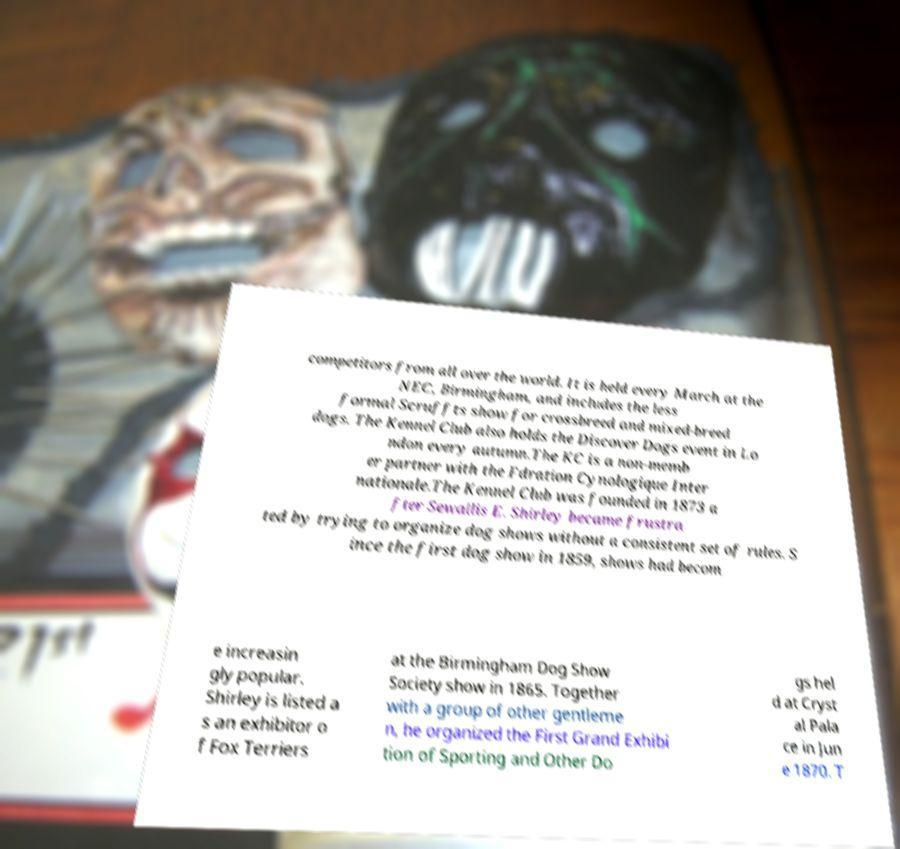There's text embedded in this image that I need extracted. Can you transcribe it verbatim? competitors from all over the world. It is held every March at the NEC, Birmingham, and includes the less formal Scruffts show for crossbreed and mixed-breed dogs. The Kennel Club also holds the Discover Dogs event in Lo ndon every autumn.The KC is a non-memb er partner with the Fdration Cynologique Inter nationale.The Kennel Club was founded in 1873 a fter Sewallis E. Shirley became frustra ted by trying to organize dog shows without a consistent set of rules. S ince the first dog show in 1859, shows had becom e increasin gly popular. Shirley is listed a s an exhibitor o f Fox Terriers at the Birmingham Dog Show Society show in 1865. Together with a group of other gentleme n, he organized the First Grand Exhibi tion of Sporting and Other Do gs hel d at Cryst al Pala ce in Jun e 1870. T 